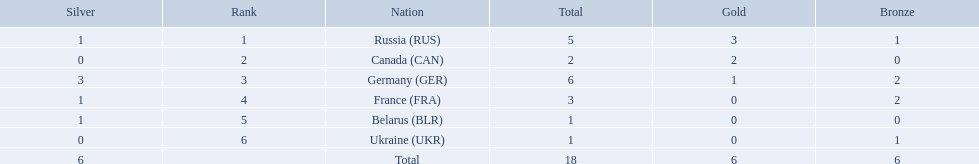Which countries competed in the 1995 biathlon? Russia (RUS), Canada (CAN), Germany (GER), France (FRA), Belarus (BLR), Ukraine (UKR). How many medals in total did they win? 5, 2, 6, 3, 1, 1. And which country had the most? Germany (GER). 